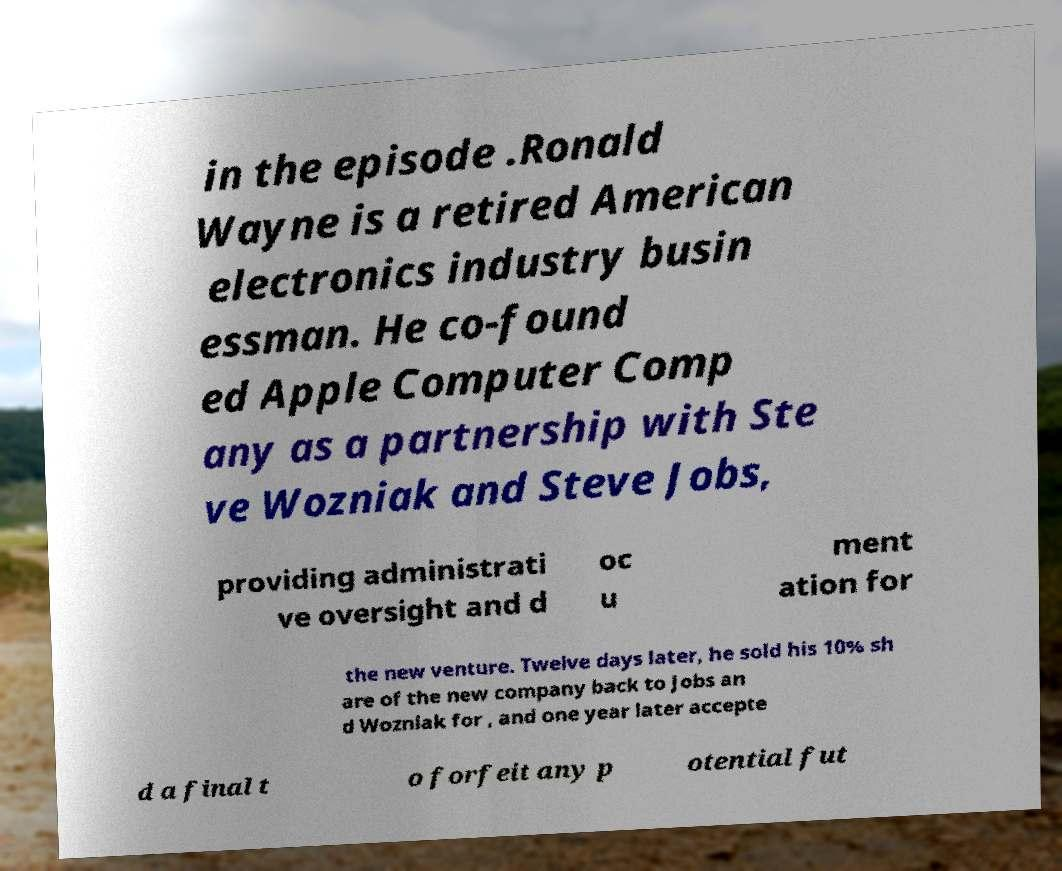Please read and relay the text visible in this image. What does it say? in the episode .Ronald Wayne is a retired American electronics industry busin essman. He co-found ed Apple Computer Comp any as a partnership with Ste ve Wozniak and Steve Jobs, providing administrati ve oversight and d oc u ment ation for the new venture. Twelve days later, he sold his 10% sh are of the new company back to Jobs an d Wozniak for , and one year later accepte d a final t o forfeit any p otential fut 